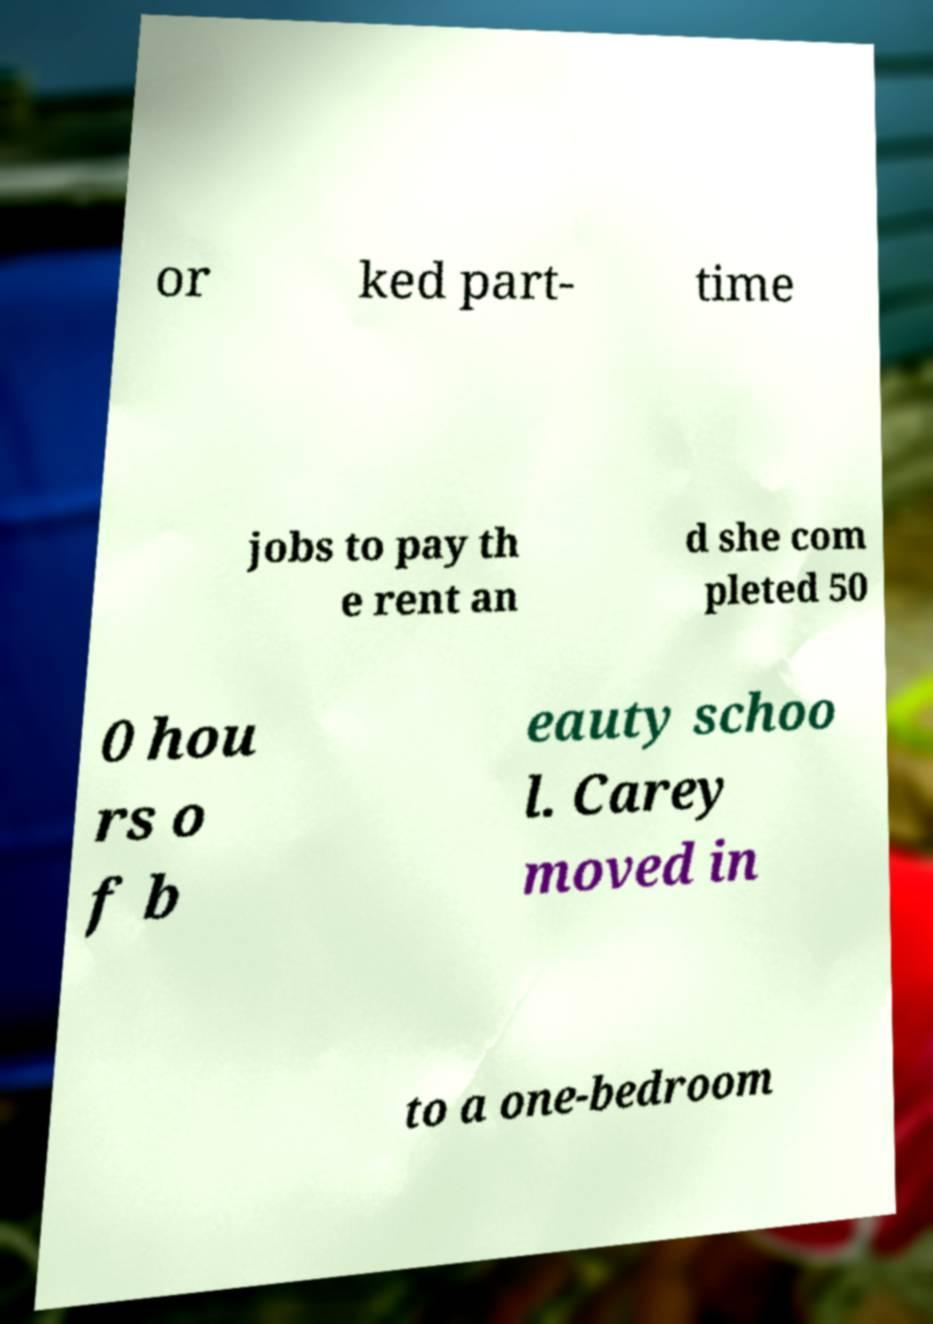Please read and relay the text visible in this image. What does it say? or ked part- time jobs to pay th e rent an d she com pleted 50 0 hou rs o f b eauty schoo l. Carey moved in to a one-bedroom 